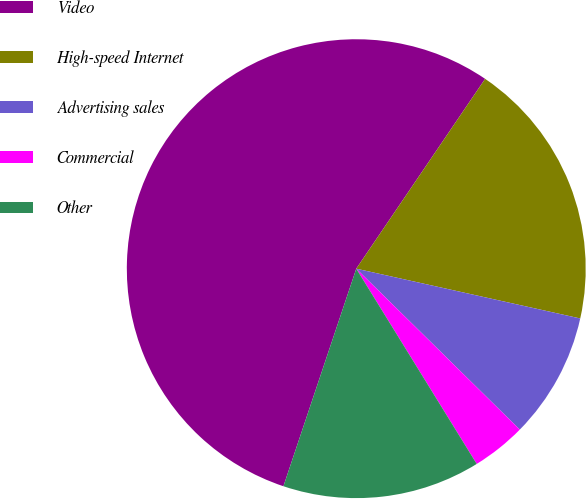Convert chart. <chart><loc_0><loc_0><loc_500><loc_500><pie_chart><fcel>Video<fcel>High-speed Internet<fcel>Advertising sales<fcel>Commercial<fcel>Other<nl><fcel>54.35%<fcel>18.99%<fcel>8.89%<fcel>3.83%<fcel>13.94%<nl></chart> 